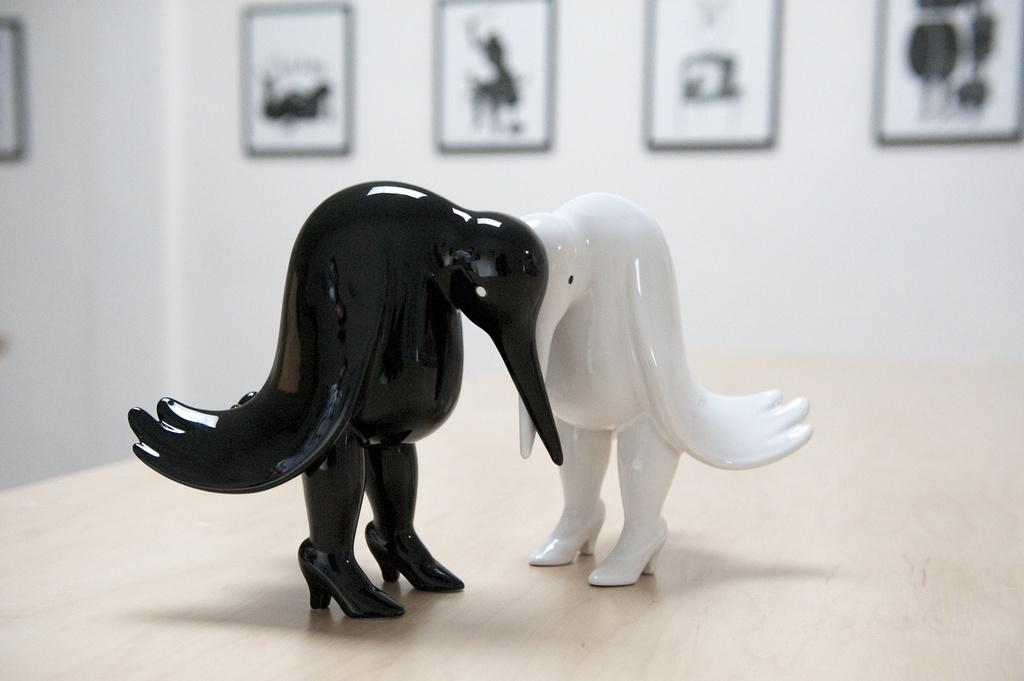What is the main object in the image? There is a table in the image. What is placed on the table? There is a toy on the table. What can be seen in the background of the image? There are photo frames in the background of the image. Where are the photo frames located? The photo frames are attached to a wall. What time of day is it in the image, and what are the people writing? There is no indication of time of day in the image, and no people are present to be writing anything. 